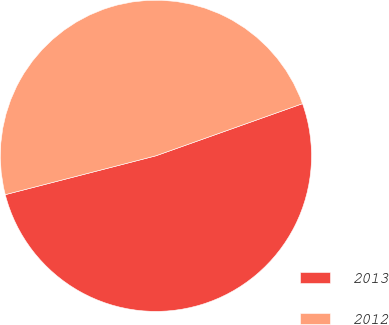<chart> <loc_0><loc_0><loc_500><loc_500><pie_chart><fcel>2013<fcel>2012<nl><fcel>51.42%<fcel>48.58%<nl></chart> 